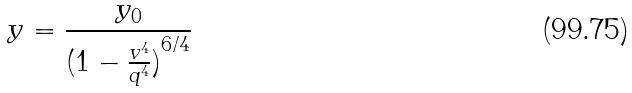Convert formula to latex. <formula><loc_0><loc_0><loc_500><loc_500>y = \frac { y _ { 0 } } { ( { 1 - \frac { v ^ { 4 } } { q ^ { 4 } } ) } ^ { 6 / 4 } }</formula> 